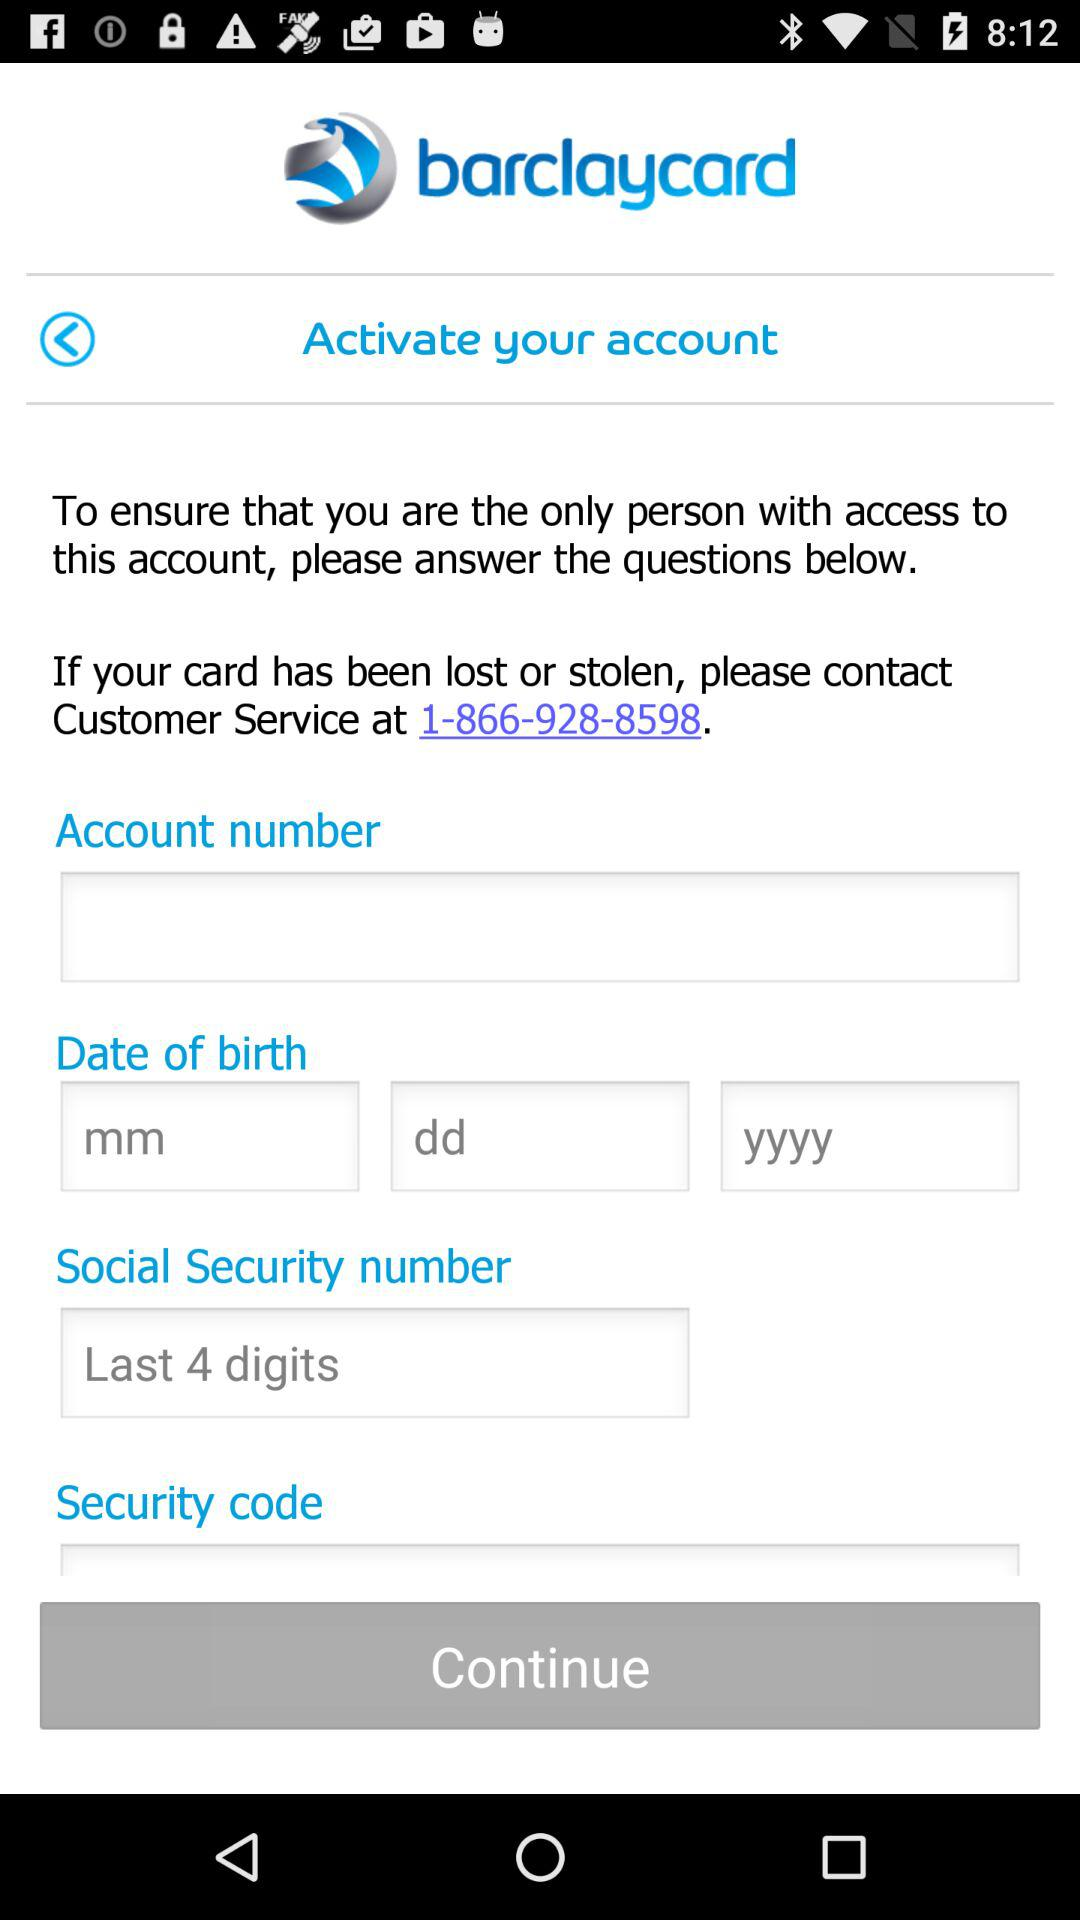What is the application name? The application name is "barclaycard". 